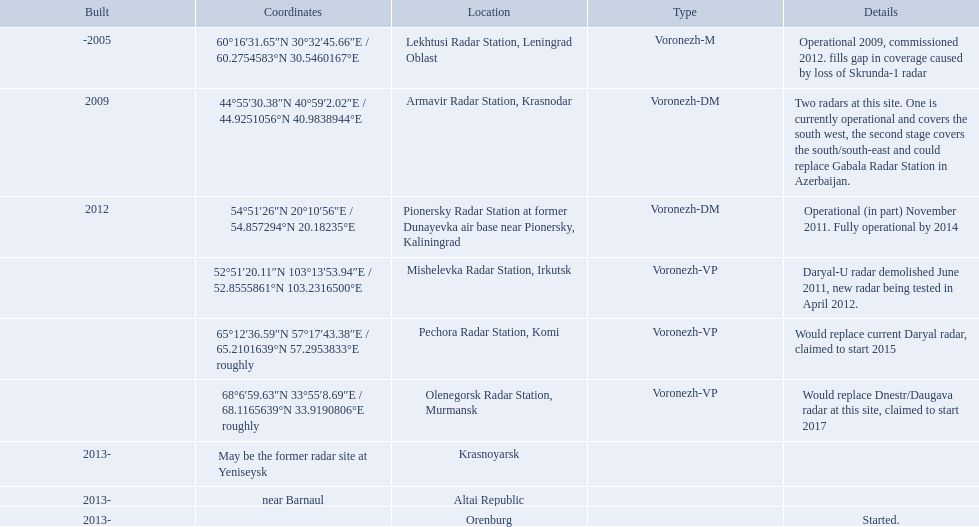Which column has the coordinates starting with 60 deg? 60°16′31.65″N 30°32′45.66″E﻿ / ﻿60.2754583°N 30.5460167°E. What is the location in the same row as that column? Lekhtusi Radar Station, Leningrad Oblast. 